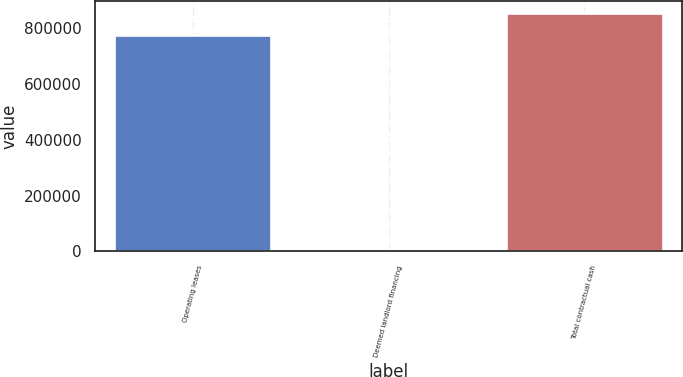<chart> <loc_0><loc_0><loc_500><loc_500><bar_chart><fcel>Operating leases<fcel>Deemed landlord financing<fcel>Total contractual cash<nl><fcel>776477<fcel>5868<fcel>854125<nl></chart> 